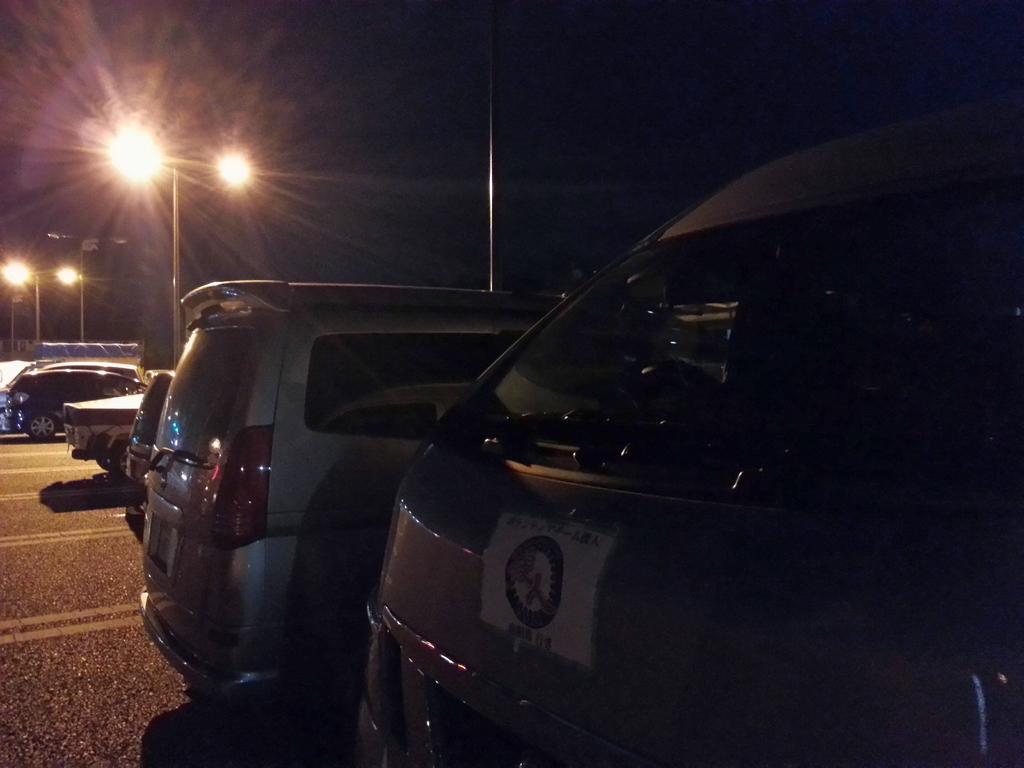Please provide a concise description of this image. As we can see in the image there are cars and lights. The image is little dark. 